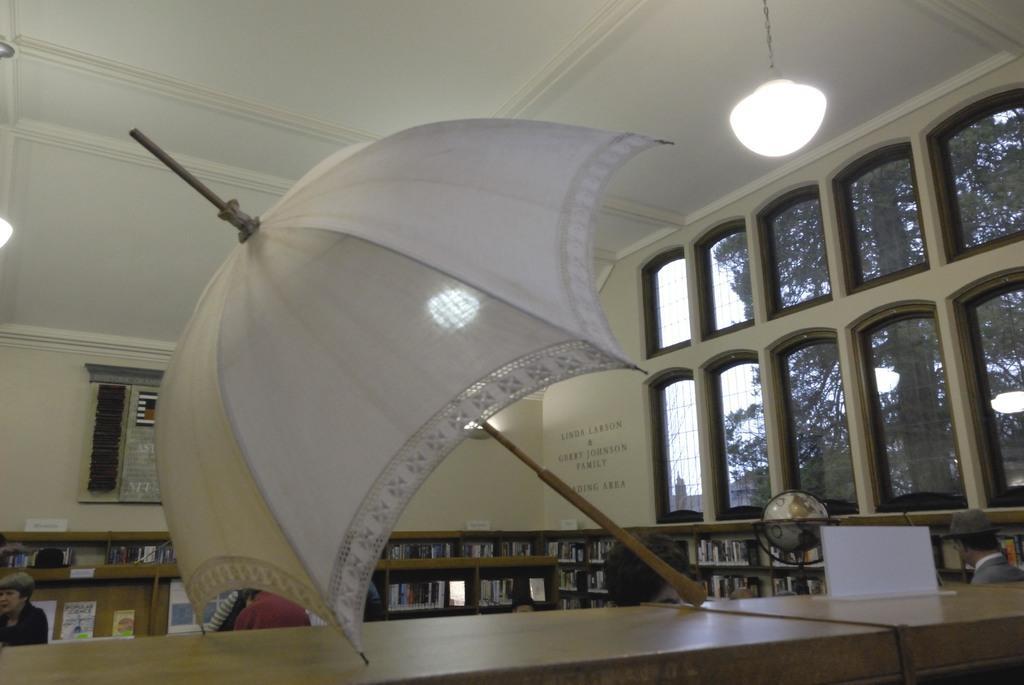Please provide a concise description of this image. In the picture I can see an umbrella. I can see the wooden tables at the bottom of the picture. There are books on the wooden shelves. I can see the glass windows on the top right side. I can see the lights onto the roof. There are trees on the right side and I can see a few persons in the picture. 